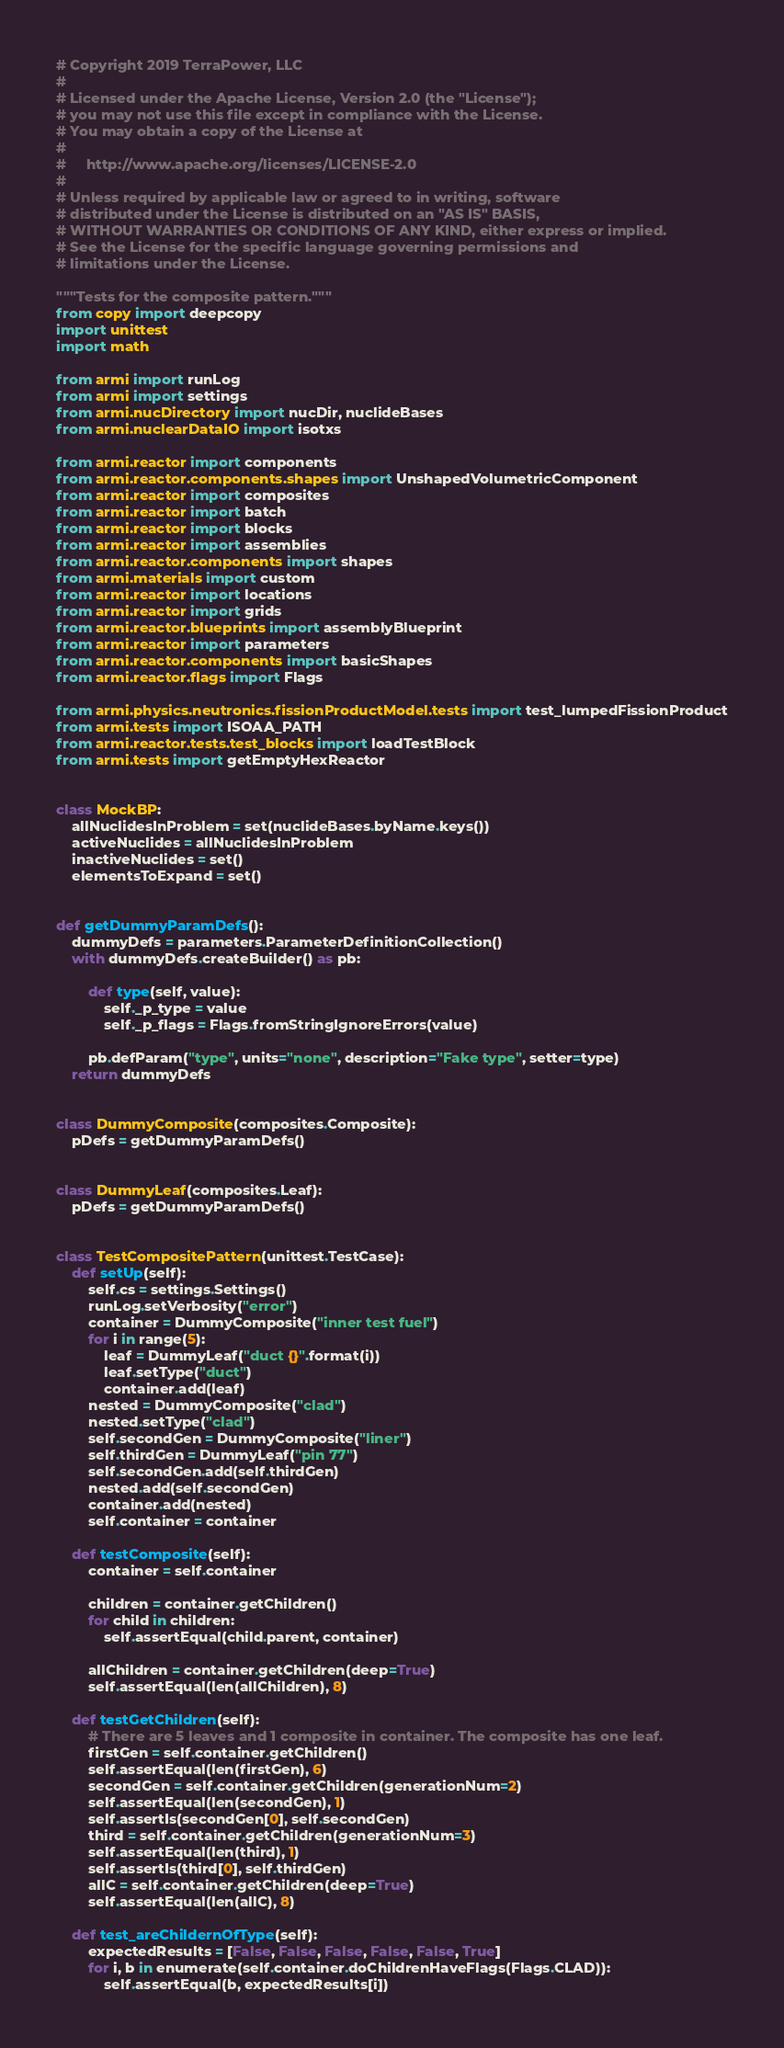<code> <loc_0><loc_0><loc_500><loc_500><_Python_># Copyright 2019 TerraPower, LLC
#
# Licensed under the Apache License, Version 2.0 (the "License");
# you may not use this file except in compliance with the License.
# You may obtain a copy of the License at
#
#     http://www.apache.org/licenses/LICENSE-2.0
#
# Unless required by applicable law or agreed to in writing, software
# distributed under the License is distributed on an "AS IS" BASIS,
# WITHOUT WARRANTIES OR CONDITIONS OF ANY KIND, either express or implied.
# See the License for the specific language governing permissions and
# limitations under the License.

"""Tests for the composite pattern."""
from copy import deepcopy
import unittest
import math

from armi import runLog
from armi import settings
from armi.nucDirectory import nucDir, nuclideBases
from armi.nuclearDataIO import isotxs

from armi.reactor import components
from armi.reactor.components.shapes import UnshapedVolumetricComponent
from armi.reactor import composites
from armi.reactor import batch
from armi.reactor import blocks
from armi.reactor import assemblies
from armi.reactor.components import shapes
from armi.materials import custom
from armi.reactor import locations
from armi.reactor import grids
from armi.reactor.blueprints import assemblyBlueprint
from armi.reactor import parameters
from armi.reactor.components import basicShapes
from armi.reactor.flags import Flags

from armi.physics.neutronics.fissionProductModel.tests import test_lumpedFissionProduct
from armi.tests import ISOAA_PATH
from armi.reactor.tests.test_blocks import loadTestBlock
from armi.tests import getEmptyHexReactor


class MockBP:
    allNuclidesInProblem = set(nuclideBases.byName.keys())
    activeNuclides = allNuclidesInProblem
    inactiveNuclides = set()
    elementsToExpand = set()


def getDummyParamDefs():
    dummyDefs = parameters.ParameterDefinitionCollection()
    with dummyDefs.createBuilder() as pb:

        def type(self, value):
            self._p_type = value
            self._p_flags = Flags.fromStringIgnoreErrors(value)

        pb.defParam("type", units="none", description="Fake type", setter=type)
    return dummyDefs


class DummyComposite(composites.Composite):
    pDefs = getDummyParamDefs()


class DummyLeaf(composites.Leaf):
    pDefs = getDummyParamDefs()


class TestCompositePattern(unittest.TestCase):
    def setUp(self):
        self.cs = settings.Settings()
        runLog.setVerbosity("error")
        container = DummyComposite("inner test fuel")
        for i in range(5):
            leaf = DummyLeaf("duct {}".format(i))
            leaf.setType("duct")
            container.add(leaf)
        nested = DummyComposite("clad")
        nested.setType("clad")
        self.secondGen = DummyComposite("liner")
        self.thirdGen = DummyLeaf("pin 77")
        self.secondGen.add(self.thirdGen)
        nested.add(self.secondGen)
        container.add(nested)
        self.container = container

    def testComposite(self):
        container = self.container

        children = container.getChildren()
        for child in children:
            self.assertEqual(child.parent, container)

        allChildren = container.getChildren(deep=True)
        self.assertEqual(len(allChildren), 8)

    def testGetChildren(self):
        # There are 5 leaves and 1 composite in container. The composite has one leaf.
        firstGen = self.container.getChildren()
        self.assertEqual(len(firstGen), 6)
        secondGen = self.container.getChildren(generationNum=2)
        self.assertEqual(len(secondGen), 1)
        self.assertIs(secondGen[0], self.secondGen)
        third = self.container.getChildren(generationNum=3)
        self.assertEqual(len(third), 1)
        self.assertIs(third[0], self.thirdGen)
        allC = self.container.getChildren(deep=True)
        self.assertEqual(len(allC), 8)

    def test_areChildernOfType(self):
        expectedResults = [False, False, False, False, False, True]
        for i, b in enumerate(self.container.doChildrenHaveFlags(Flags.CLAD)):
            self.assertEqual(b, expectedResults[i])
</code> 